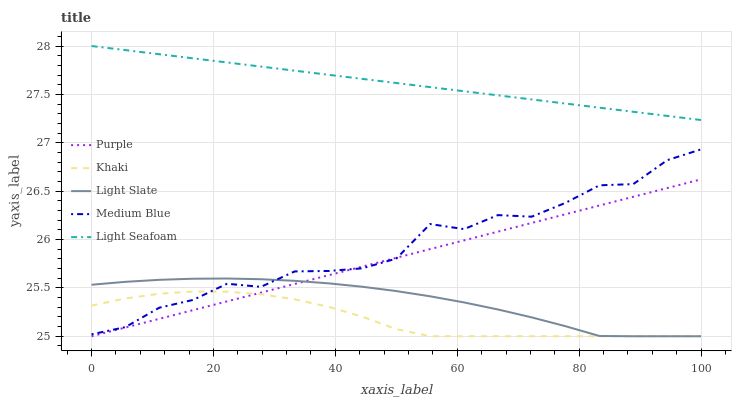Does Khaki have the minimum area under the curve?
Answer yes or no. Yes. Does Light Seafoam have the maximum area under the curve?
Answer yes or no. Yes. Does Light Slate have the minimum area under the curve?
Answer yes or no. No. Does Light Slate have the maximum area under the curve?
Answer yes or no. No. Is Light Seafoam the smoothest?
Answer yes or no. Yes. Is Medium Blue the roughest?
Answer yes or no. Yes. Is Light Slate the smoothest?
Answer yes or no. No. Is Light Slate the roughest?
Answer yes or no. No. Does Purple have the lowest value?
Answer yes or no. Yes. Does Medium Blue have the lowest value?
Answer yes or no. No. Does Light Seafoam have the highest value?
Answer yes or no. Yes. Does Light Slate have the highest value?
Answer yes or no. No. Is Light Slate less than Light Seafoam?
Answer yes or no. Yes. Is Light Seafoam greater than Light Slate?
Answer yes or no. Yes. Does Khaki intersect Purple?
Answer yes or no. Yes. Is Khaki less than Purple?
Answer yes or no. No. Is Khaki greater than Purple?
Answer yes or no. No. Does Light Slate intersect Light Seafoam?
Answer yes or no. No. 